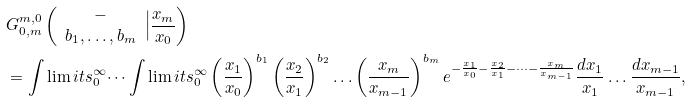Convert formula to latex. <formula><loc_0><loc_0><loc_500><loc_500>& G ^ { m , 0 } _ { 0 , m } \left ( \begin{array} { c c c } - \\ b _ { 1 } , \dots , b _ { m } \end{array} \Big | \frac { x _ { m } } { x _ { 0 } } \right ) \\ & = \int \lim i t s _ { 0 } ^ { \infty } \dots \int \lim i t s _ { 0 } ^ { \infty } \left ( \frac { x _ { 1 } } { x _ { 0 } } \right ) ^ { b _ { 1 } } \left ( \frac { x _ { 2 } } { x _ { 1 } } \right ) ^ { b _ { 2 } } \dots \left ( \frac { x _ { m } } { x _ { m - 1 } } \right ) ^ { b _ { m } } e ^ { - \frac { x _ { 1 } } { x _ { 0 } } - \frac { x _ { 2 } } { x _ { 1 } } - \dots - \frac { x _ { m } } { x _ { m - 1 } } } \frac { d x _ { 1 } } { x _ { 1 } } \dots \frac { d x _ { m - 1 } } { x _ { m - 1 } } ,</formula> 